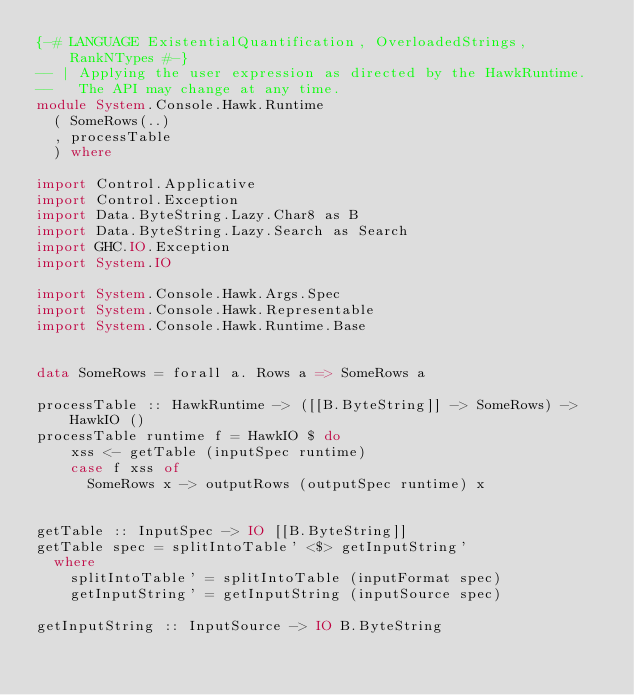<code> <loc_0><loc_0><loc_500><loc_500><_Haskell_>{-# LANGUAGE ExistentialQuantification, OverloadedStrings, RankNTypes #-}
-- | Applying the user expression as directed by the HawkRuntime.
--   The API may change at any time.
module System.Console.Hawk.Runtime
  ( SomeRows(..)
  , processTable
  ) where

import Control.Applicative
import Control.Exception
import Data.ByteString.Lazy.Char8 as B
import Data.ByteString.Lazy.Search as Search
import GHC.IO.Exception
import System.IO

import System.Console.Hawk.Args.Spec
import System.Console.Hawk.Representable
import System.Console.Hawk.Runtime.Base


data SomeRows = forall a. Rows a => SomeRows a

processTable :: HawkRuntime -> ([[B.ByteString]] -> SomeRows) -> HawkIO ()
processTable runtime f = HawkIO $ do
    xss <- getTable (inputSpec runtime)
    case f xss of
      SomeRows x -> outputRows (outputSpec runtime) x


getTable :: InputSpec -> IO [[B.ByteString]]
getTable spec = splitIntoTable' <$> getInputString'
  where
    splitIntoTable' = splitIntoTable (inputFormat spec)
    getInputString' = getInputString (inputSource spec)

getInputString :: InputSource -> IO B.ByteString</code> 